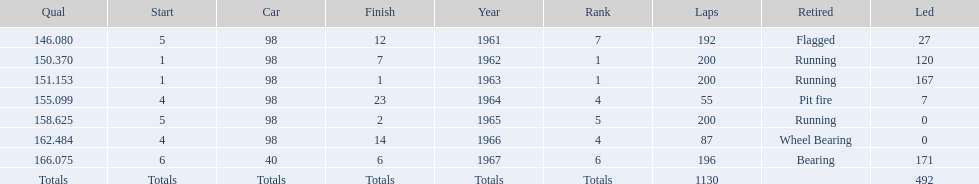How many consecutive years did parnelli place in the top 5? 5. 